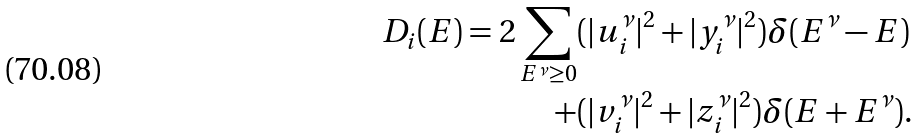Convert formula to latex. <formula><loc_0><loc_0><loc_500><loc_500>D _ { i } ( E ) = 2 \sum _ { E ^ { \nu } \geq 0 } & ( | u _ { i } ^ { \nu } | ^ { 2 } + | y _ { i } ^ { \nu } | ^ { 2 } ) \delta ( E ^ { \nu } - E ) \\ + & ( | v _ { i } ^ { \nu } | ^ { 2 } + | z _ { i } ^ { \nu } | ^ { 2 } ) \delta ( E + E ^ { \nu } ) .</formula> 